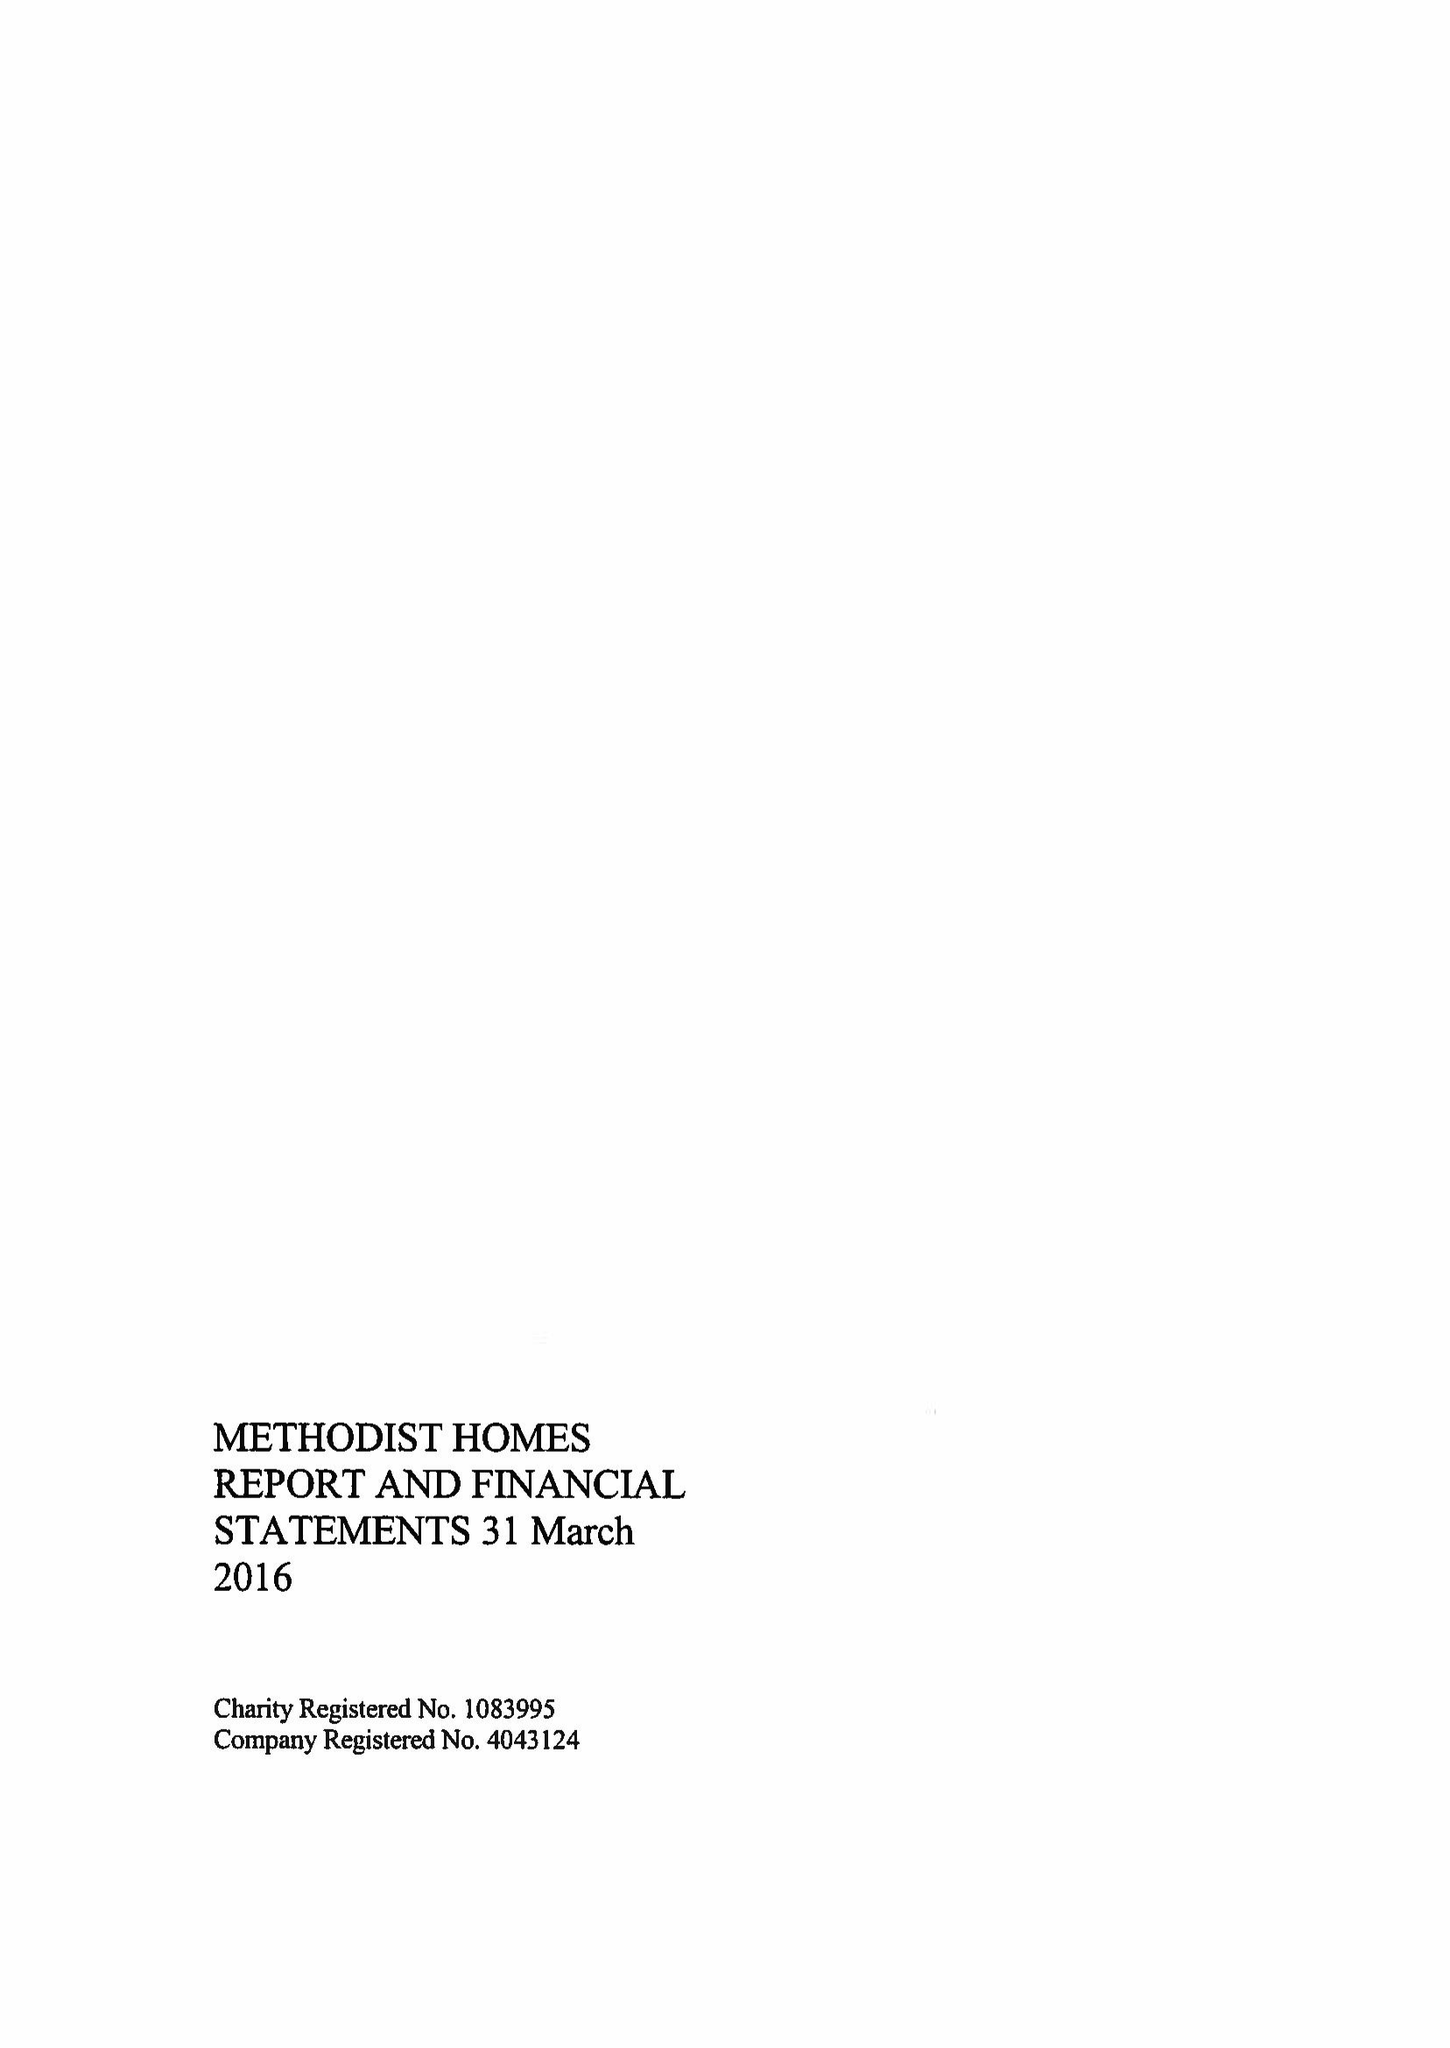What is the value for the income_annually_in_british_pounds?
Answer the question using a single word or phrase. 191468000.00 